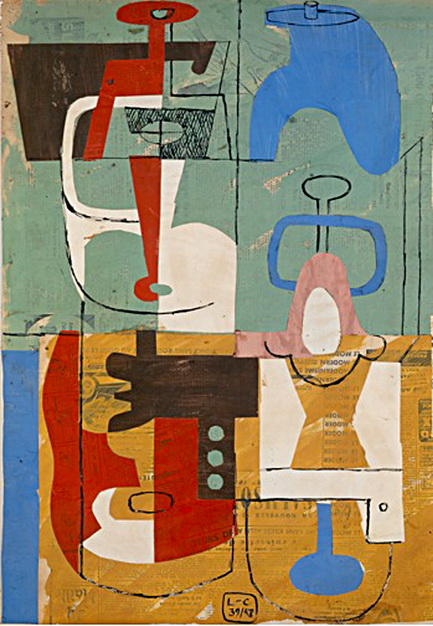Can you explain the cubist influences in this painting? The cubist influences in this painting are evident in the use of geometric shapes and the fragmentation of the image into distinct sections. Cubism, an art movement pioneered by artists like Pablo Picasso and Georges Braque, is characterized by the deconstruction and reassembly of objects into abstract forms. In this artwork, the artist has employed a similar approach, breaking down elements into simplified geometric shapes and rearranging them to create a visually engaging composition.

The painting features overlapping shapes that create a sense of depth and perspective, a hallmark of cubist art. The varied angles and lines further emphasize the abstract nature of the piece, challenging the viewer to interpret the image from multiple viewpoints simultaneously. This technique not only adds complexity to the artwork but also invites a deeper exploration of its form and structure. 